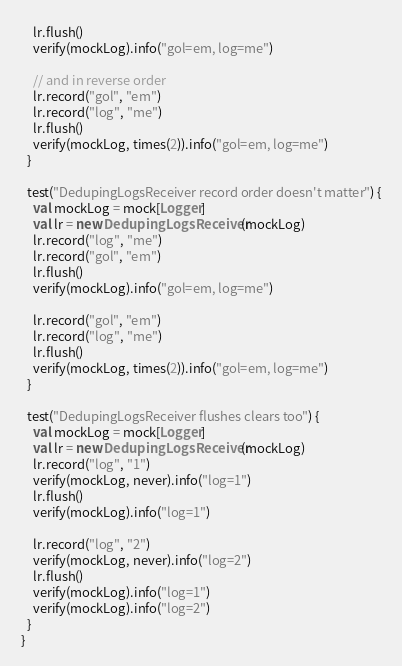<code> <loc_0><loc_0><loc_500><loc_500><_Scala_>    lr.flush()
    verify(mockLog).info("gol=em, log=me")

    // and in reverse order
    lr.record("gol", "em")
    lr.record("log", "me")
    lr.flush()
    verify(mockLog, times(2)).info("gol=em, log=me")
  }

  test("DedupingLogsReceiver record order doesn't matter") {
    val mockLog = mock[Logger]
    val lr = new DedupingLogsReceiver(mockLog)
    lr.record("log", "me")
    lr.record("gol", "em")
    lr.flush()
    verify(mockLog).info("gol=em, log=me")

    lr.record("gol", "em")
    lr.record("log", "me")
    lr.flush()
    verify(mockLog, times(2)).info("gol=em, log=me")
  }

  test("DedupingLogsReceiver flushes clears too") {
    val mockLog = mock[Logger]
    val lr = new DedupingLogsReceiver(mockLog)
    lr.record("log", "1")
    verify(mockLog, never).info("log=1")
    lr.flush()
    verify(mockLog).info("log=1")

    lr.record("log", "2")
    verify(mockLog, never).info("log=2")
    lr.flush()
    verify(mockLog).info("log=1")
    verify(mockLog).info("log=2")
  }
}
</code> 